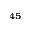<formula> <loc_0><loc_0><loc_500><loc_500>^ { 4 5 }</formula> 